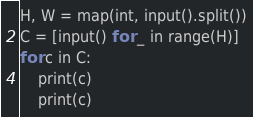<code> <loc_0><loc_0><loc_500><loc_500><_Python_>H, W = map(int, input().split())
C = [input() for _ in range(H)]
for c in C:
    print(c)
    print(c)
</code> 